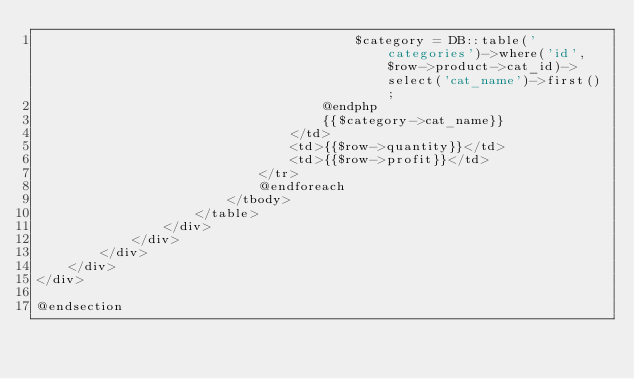<code> <loc_0><loc_0><loc_500><loc_500><_PHP_>                                        $category = DB::table('categories')->where('id', $row->product->cat_id)->select('cat_name')->first();
                                    @endphp
                                    {{$category->cat_name}}
                                </td>
                                <td>{{$row->quantity}}</td>
                                <td>{{$row->profit}}</td>
                            </tr>
                            @endforeach 
                        </tbody>
                    </table>
                </div>
            </div>
        </div>
    </div>
</div>

@endsection </code> 